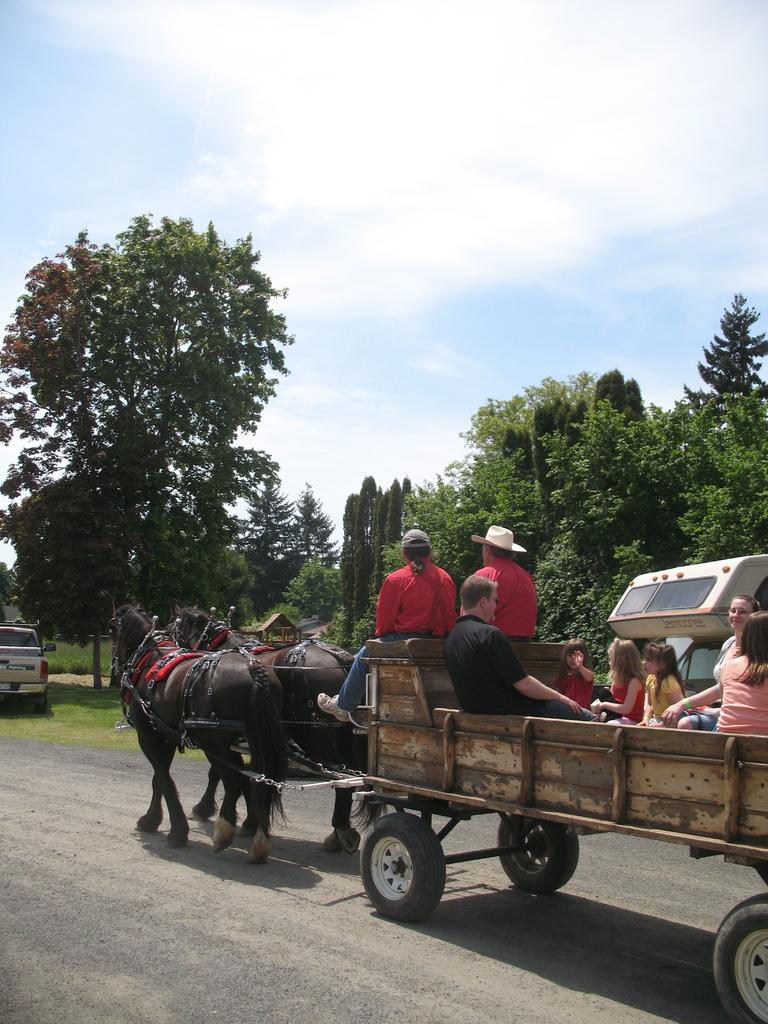Could you give a brief overview of what you see in this image? There is a horse cart in which a crowd is travelling on a road and behind them there is a car parked and so many trees around them. 